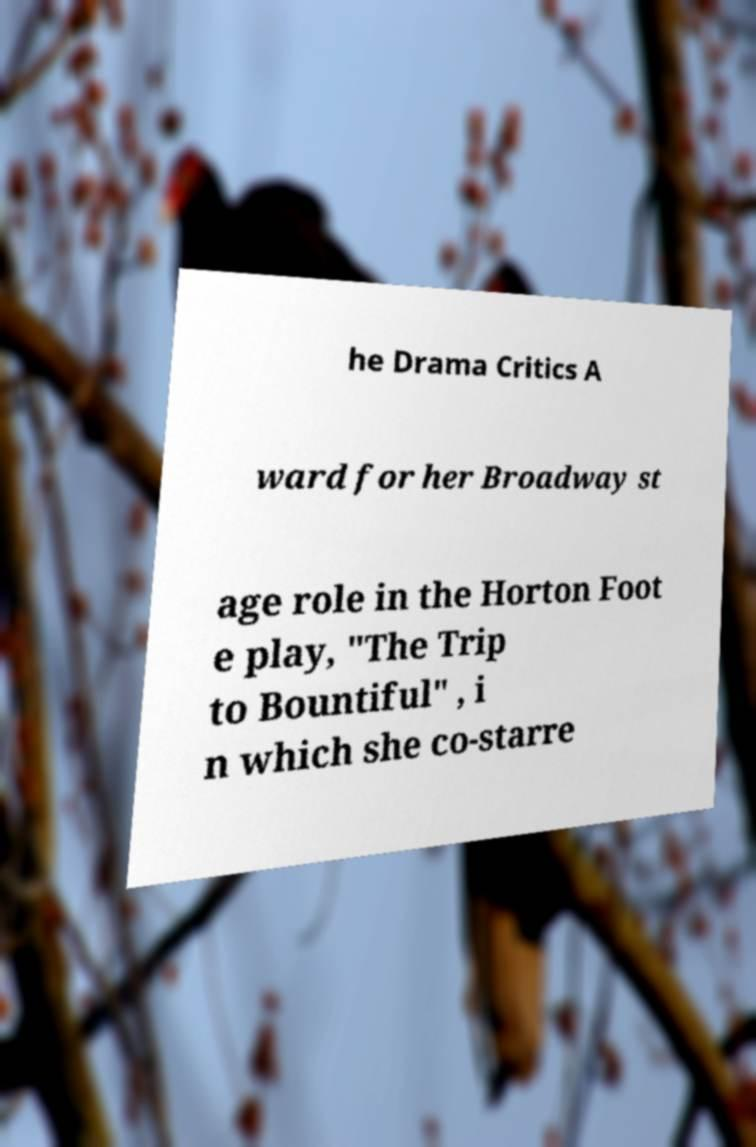What messages or text are displayed in this image? I need them in a readable, typed format. he Drama Critics A ward for her Broadway st age role in the Horton Foot e play, "The Trip to Bountiful" , i n which she co-starre 